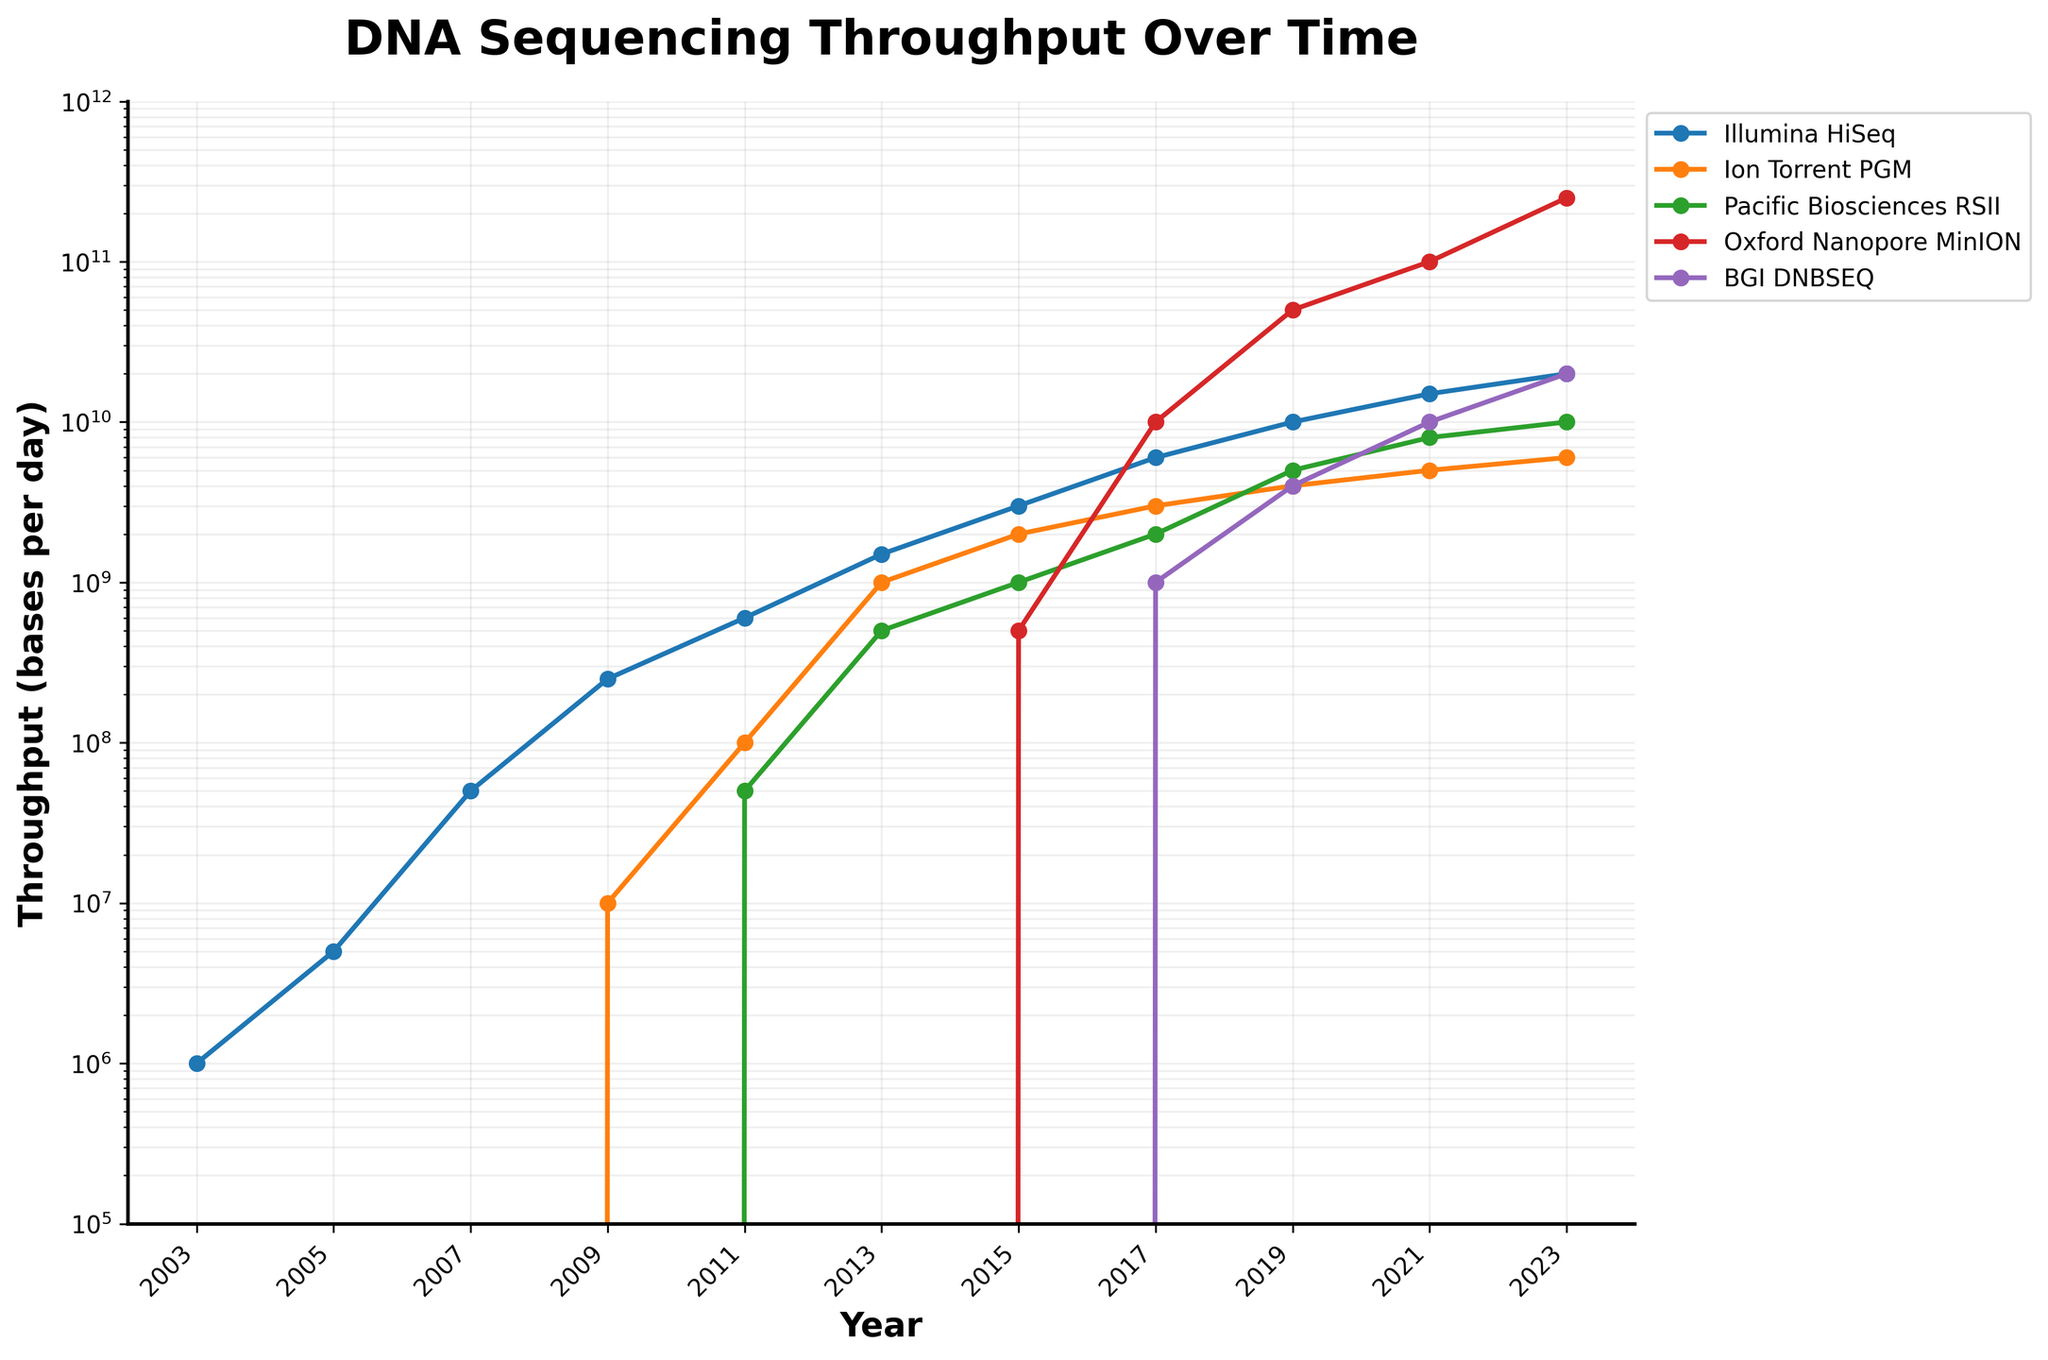What is the throughput of Illumina HiSeq in 2009? Locate the point on the Illumina HiSeq line corresponding to the year 2009. The throughput is marked as 250,000,000 bases per day.
Answer: 250,000,000 Which sequencing machine had the highest throughput in 2023? Compare the endpoints of all the sequencing machine lines for the year 2023. The Oxford Nanopore MinION has the highest throughput, reaching 250,000,000,000 bases per day.
Answer: Oxford Nanopore MinION How did the throughput of the Ion Torrent PGM change from 2011 to 2013? Locate the points on the Ion Torrent PGM line for the years 2011 and 2013. Subtract the 2011 throughput (100,000,000) from the 2013 throughput (1,000,000,000) to find the change: 1,000,000,000 - 100,000,000 is 900,000,000.
Answer: Increased by 900,000,000 Which sequencing machine showed the most significant increase in throughput between 2019 and 2021? Examine the difference in throughput values for each sequencing machine from 2019 to 2021. The Oxford Nanopore MinION throughput increased from 50,000,000,000 to 100,000,000,000, a change of 50,000,000,000 bases per day, which is the largest increase among all machines.
Answer: Oxford Nanopore MinION Compare the throughput of Pacific Biosciences RSII and BGI DNBSEQ in 2021. Which one was higher, and by how much? Note the throughput points for Pacific Biosciences RSII (8,000,000,000) and BGI DNBSEQ (10,000,000,000) in 2021. Subtract the value for Pacific Biosciences RSII from that of BGI DNBSEQ: 10,000,000,000 - 8,000,000,000 = 2,000,000,000.
Answer: BGI DNBSEQ by 2,000,000,000 What visual pattern do you observe in the throughput trends of all the sequencing machines over the years? Observe the overall direction of the lines for all machines, noting steep increases. All machines show exponential growth in throughput over time, highlighted by the logarithmic y-axis scale.
Answer: Exponential growth How many times greater is the throughput of Illumina HiSeq in 2023 compared to 2003? Divide the throughput in 2023 (20,000,000,000) by the throughput in 2003 (1,000,000): 20,000,000,000 ÷ 1,000,000 = 20,000.
Answer: 20,000 times By how much did the Oxford Nanopore MinION throughput increase from 2015 to 2023? Subtract the 2015 throughput (500,000,000) from the 2023 throughput (250,000,000,000): 250,000,000,000 - 500,000,000 = 249,500,000,000.
Answer: 249,500,000,000 